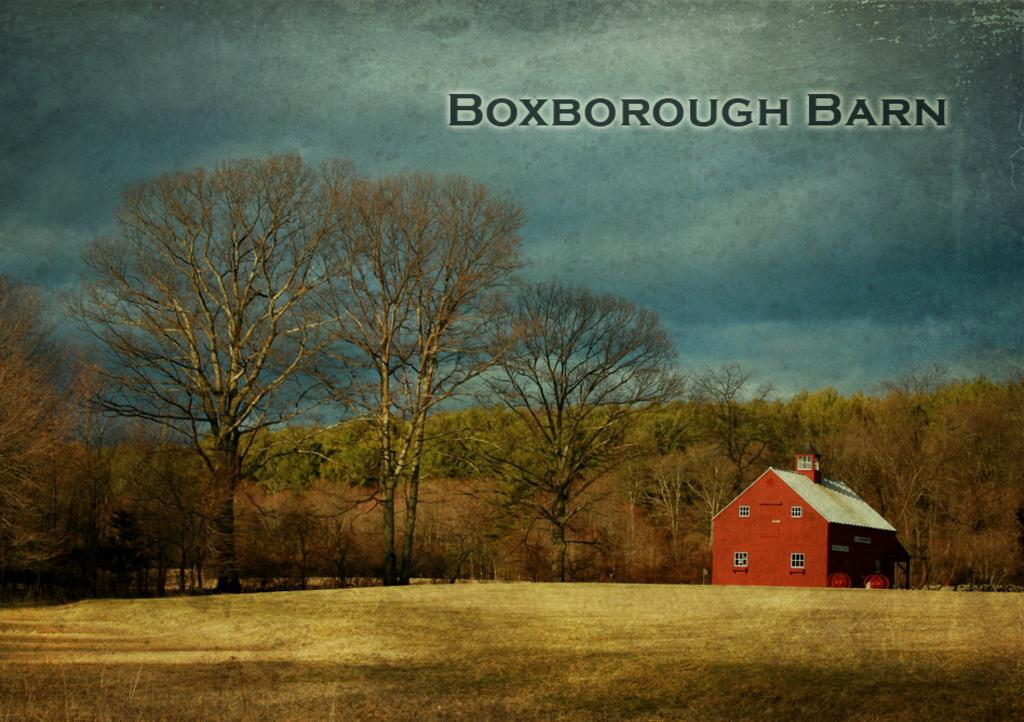What type of natural elements can be seen in the image? There are trees and hills visible in the image. What type of structure can be seen in the image? There is a shed in the image. What part of the landscape is visible at the bottom of the image? The ground is visible at the bottom of the image. What is written or displayed at the top of the image? There is text visible at the top of the image. What type of camera can be seen in the image? There is no camera visible in the image. What type of industry is depicted in the image? There is no industry depicted in the image; it features trees, hills, a shed, and text. 